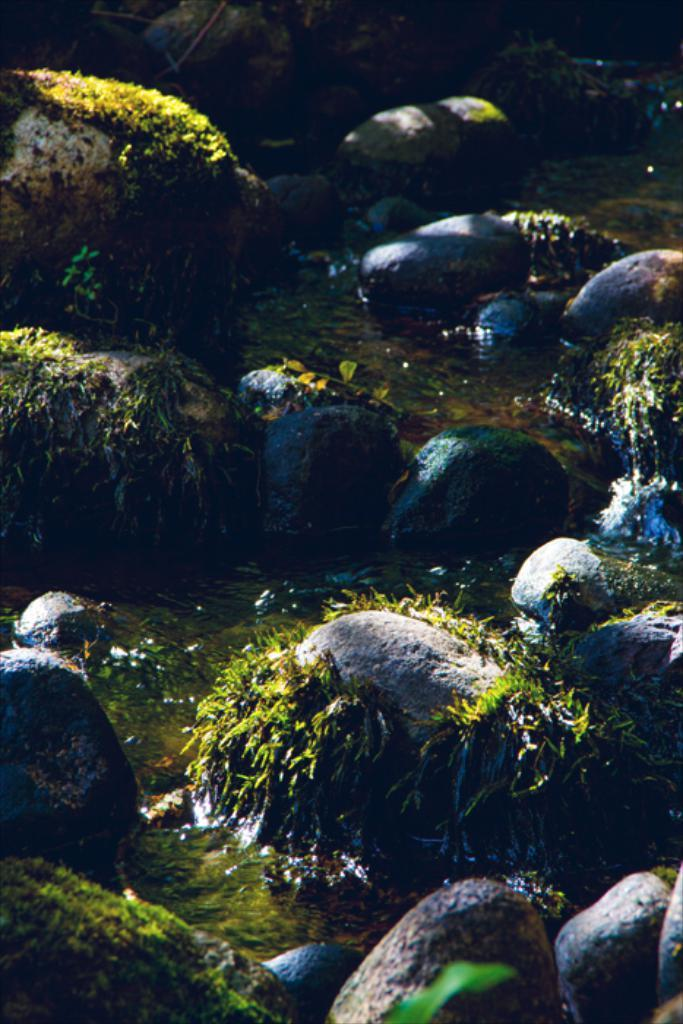What can be seen in the foreground of the image? In the foreground of the image, there are rocks, grass, and water. What type of environment might the image depict? The image may have been taken near a river, given the presence of water and the possible association with rocks and grass. Where is the throne located in the image? There is no throne present in the image. Can you describe the process of the rocks changing color in the image? The rocks do not change color in the image; they remain the same throughout. 